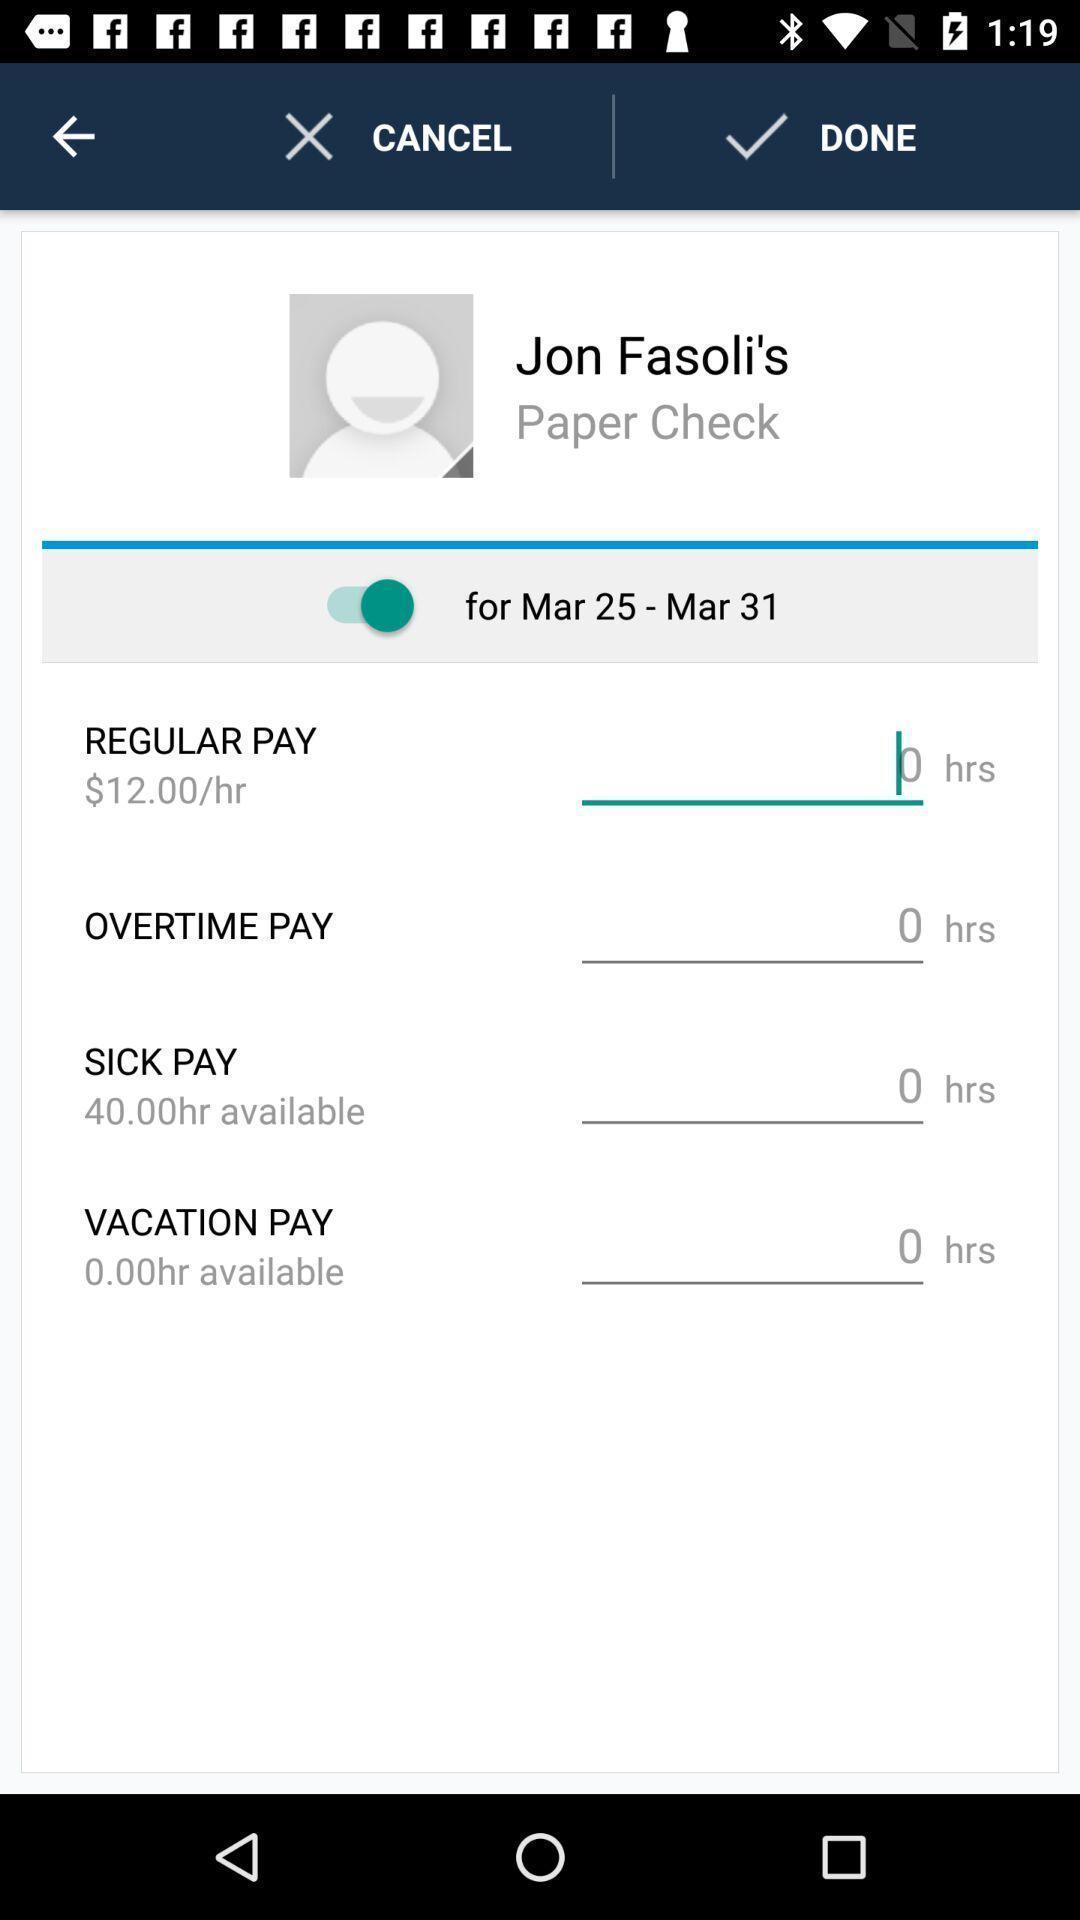Provide a textual representation of this image. Screen display employee pay details in a financial app. 